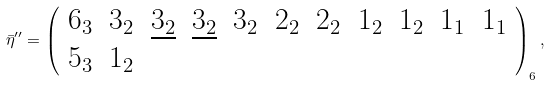<formula> <loc_0><loc_0><loc_500><loc_500>\bar { \eta } ^ { \prime \prime } = \left ( \begin{array} { c c c c c c c c c c c c c } 6 _ { 3 } & 3 _ { 2 } & \underline { 3 _ { 2 } } & \underline { 3 _ { 2 } } & 3 _ { 2 } & 2 _ { 2 } & 2 _ { 2 } & 1 _ { 2 } & 1 _ { 2 } & 1 _ { 1 } & 1 _ { 1 } \\ 5 _ { 3 } & 1 _ { 2 } \end{array} \right ) _ { 6 } ,</formula> 